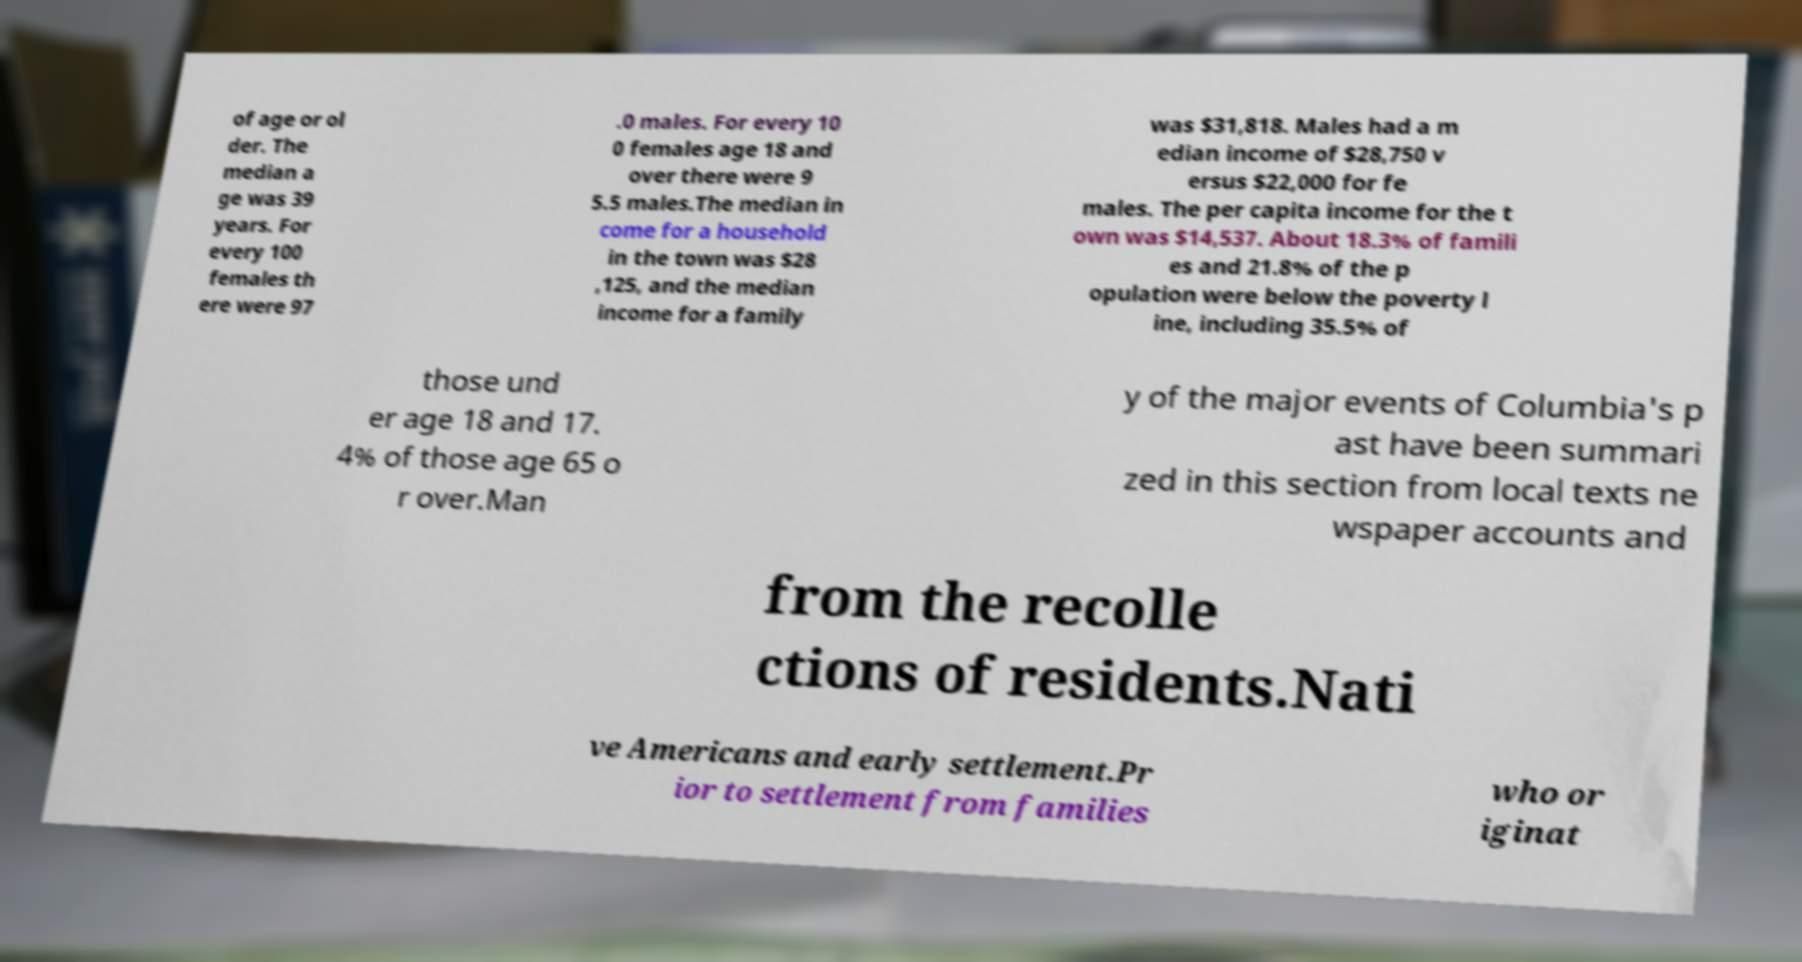Please identify and transcribe the text found in this image. of age or ol der. The median a ge was 39 years. For every 100 females th ere were 97 .0 males. For every 10 0 females age 18 and over there were 9 5.5 males.The median in come for a household in the town was $28 ,125, and the median income for a family was $31,818. Males had a m edian income of $28,750 v ersus $22,000 for fe males. The per capita income for the t own was $14,537. About 18.3% of famili es and 21.8% of the p opulation were below the poverty l ine, including 35.5% of those und er age 18 and 17. 4% of those age 65 o r over.Man y of the major events of Columbia's p ast have been summari zed in this section from local texts ne wspaper accounts and from the recolle ctions of residents.Nati ve Americans and early settlement.Pr ior to settlement from families who or iginat 